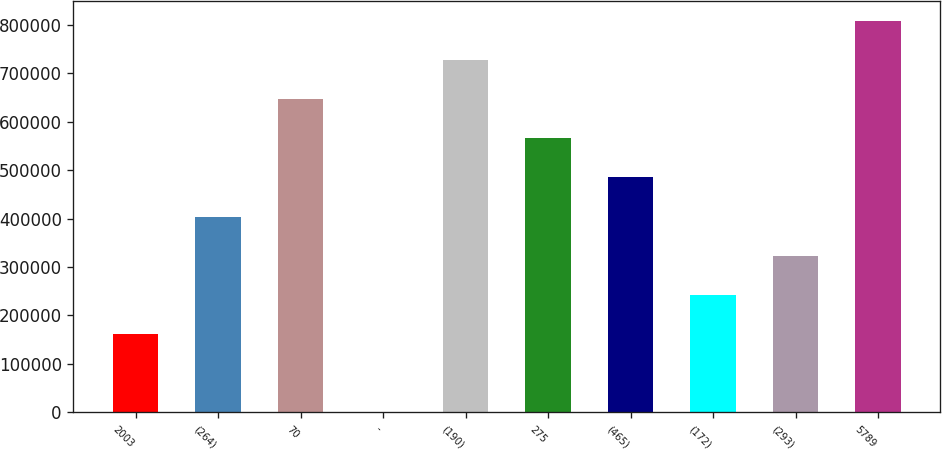Convert chart. <chart><loc_0><loc_0><loc_500><loc_500><bar_chart><fcel>2003<fcel>(264)<fcel>70<fcel>-<fcel>(190)<fcel>275<fcel>(465)<fcel>(172)<fcel>(293)<fcel>5789<nl><fcel>161750<fcel>404222<fcel>646695<fcel>102<fcel>727519<fcel>565871<fcel>485047<fcel>242574<fcel>323398<fcel>808343<nl></chart> 